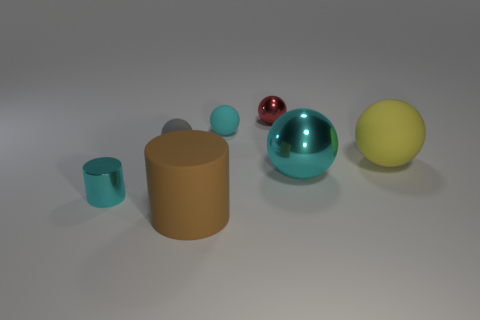What number of other things are the same color as the shiny cylinder?
Offer a terse response. 2. What color is the large thing in front of the large cyan ball?
Offer a terse response. Brown. Are there any brown cylinders that have the same size as the red shiny sphere?
Provide a short and direct response. No. There is a cylinder that is the same size as the yellow rubber ball; what is its material?
Make the answer very short. Rubber. What number of things are large things on the right side of the red metallic ball or matte things in front of the cyan shiny ball?
Offer a terse response. 3. Are there any cyan rubber things of the same shape as the tiny gray rubber thing?
Your response must be concise. Yes. What is the material of the cylinder that is the same color as the large metal thing?
Your answer should be compact. Metal. What number of matte objects are gray objects or brown things?
Your answer should be compact. 2. What shape is the red object?
Offer a terse response. Sphere. How many yellow things are the same material as the big cylinder?
Your response must be concise. 1. 